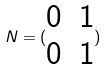<formula> <loc_0><loc_0><loc_500><loc_500>N = ( \begin{matrix} 0 & 1 \\ 0 & 1 \end{matrix} )</formula> 